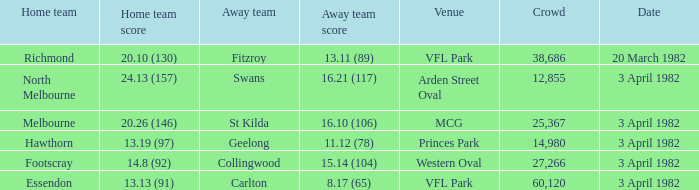Which home team played the away team of collingwood? Footscray. 